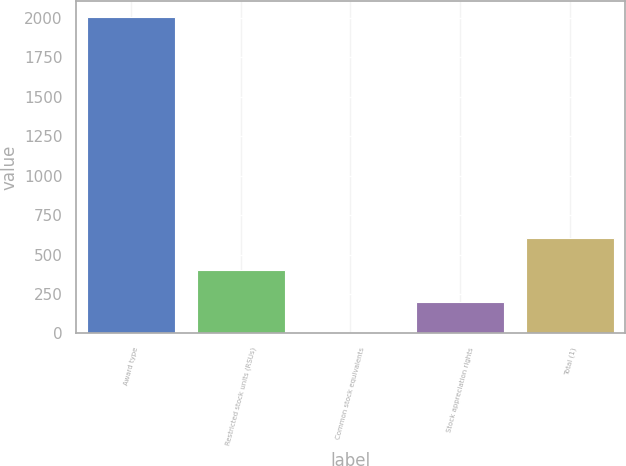Convert chart. <chart><loc_0><loc_0><loc_500><loc_500><bar_chart><fcel>Award type<fcel>Restricted stock units (RSUs)<fcel>Common stock equivalents<fcel>Stock appreciation rights<fcel>Total (1)<nl><fcel>2008<fcel>401.92<fcel>0.4<fcel>201.16<fcel>602.68<nl></chart> 